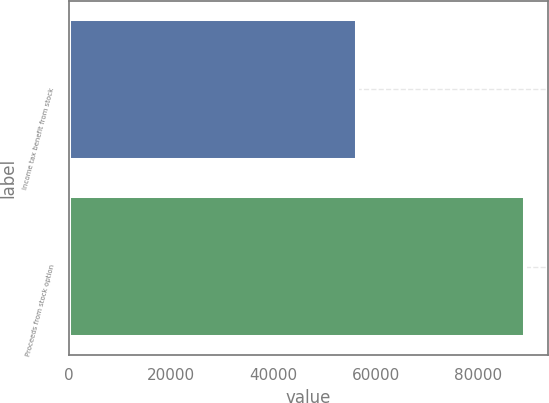<chart> <loc_0><loc_0><loc_500><loc_500><bar_chart><fcel>Income tax benefit from stock<fcel>Proceeds from stock option<nl><fcel>56351<fcel>89113<nl></chart> 